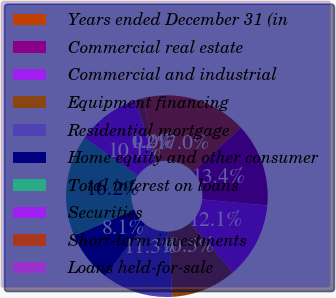<chart> <loc_0><loc_0><loc_500><loc_500><pie_chart><fcel>Years ended December 31 (in<fcel>Commercial real estate<fcel>Commercial and industrial<fcel>Equipment financing<fcel>Residential mortgage<fcel>Home equity and other consumer<fcel>Total interest on loans<fcel>Securities<fcel>Short-term investments<fcel>Loans held-for-sale<nl><fcel>17.0%<fcel>13.36%<fcel>12.15%<fcel>10.53%<fcel>11.34%<fcel>8.1%<fcel>16.19%<fcel>10.12%<fcel>1.22%<fcel>0.0%<nl></chart> 